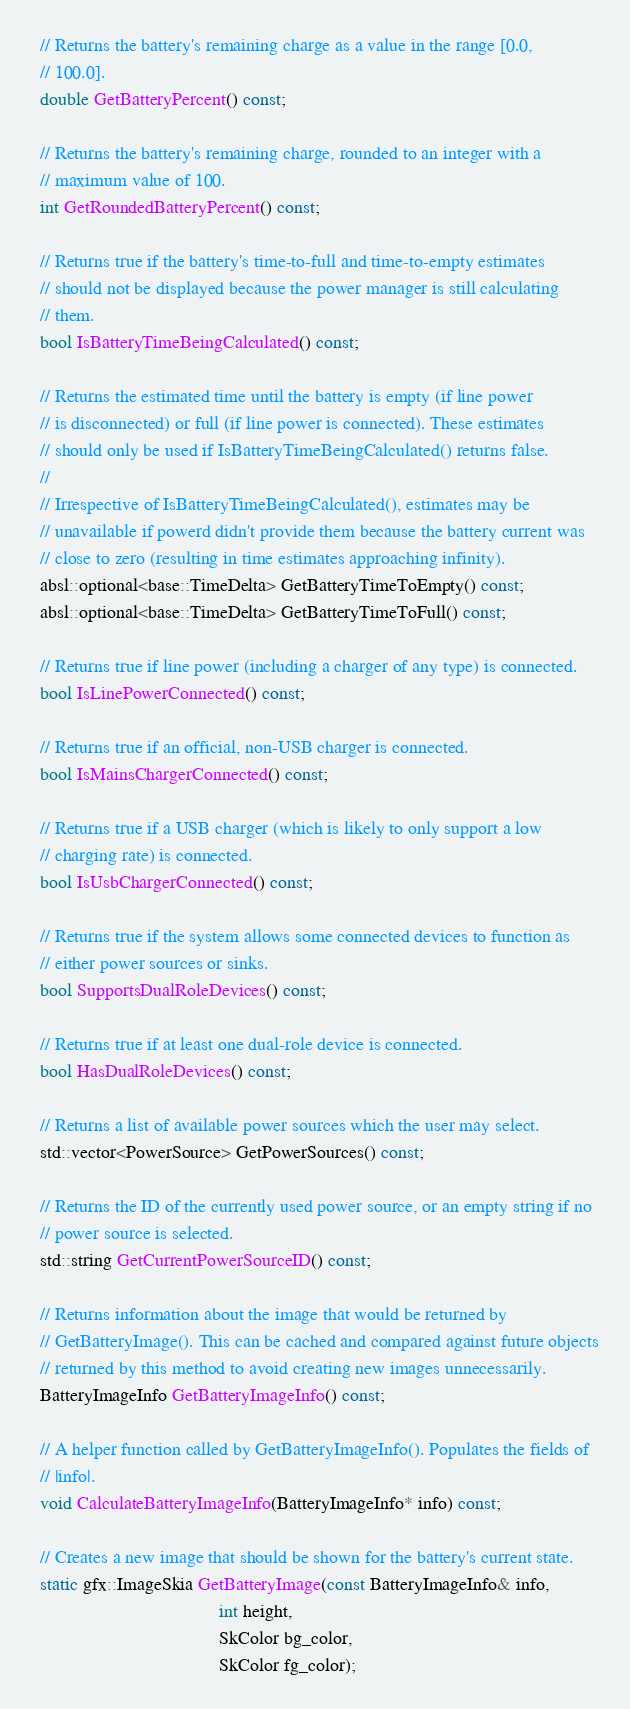<code> <loc_0><loc_0><loc_500><loc_500><_C_>
  // Returns the battery's remaining charge as a value in the range [0.0,
  // 100.0].
  double GetBatteryPercent() const;

  // Returns the battery's remaining charge, rounded to an integer with a
  // maximum value of 100.
  int GetRoundedBatteryPercent() const;

  // Returns true if the battery's time-to-full and time-to-empty estimates
  // should not be displayed because the power manager is still calculating
  // them.
  bool IsBatteryTimeBeingCalculated() const;

  // Returns the estimated time until the battery is empty (if line power
  // is disconnected) or full (if line power is connected). These estimates
  // should only be used if IsBatteryTimeBeingCalculated() returns false.
  //
  // Irrespective of IsBatteryTimeBeingCalculated(), estimates may be
  // unavailable if powerd didn't provide them because the battery current was
  // close to zero (resulting in time estimates approaching infinity).
  absl::optional<base::TimeDelta> GetBatteryTimeToEmpty() const;
  absl::optional<base::TimeDelta> GetBatteryTimeToFull() const;

  // Returns true if line power (including a charger of any type) is connected.
  bool IsLinePowerConnected() const;

  // Returns true if an official, non-USB charger is connected.
  bool IsMainsChargerConnected() const;

  // Returns true if a USB charger (which is likely to only support a low
  // charging rate) is connected.
  bool IsUsbChargerConnected() const;

  // Returns true if the system allows some connected devices to function as
  // either power sources or sinks.
  bool SupportsDualRoleDevices() const;

  // Returns true if at least one dual-role device is connected.
  bool HasDualRoleDevices() const;

  // Returns a list of available power sources which the user may select.
  std::vector<PowerSource> GetPowerSources() const;

  // Returns the ID of the currently used power source, or an empty string if no
  // power source is selected.
  std::string GetCurrentPowerSourceID() const;

  // Returns information about the image that would be returned by
  // GetBatteryImage(). This can be cached and compared against future objects
  // returned by this method to avoid creating new images unnecessarily.
  BatteryImageInfo GetBatteryImageInfo() const;

  // A helper function called by GetBatteryImageInfo(). Populates the fields of
  // |info|.
  void CalculateBatteryImageInfo(BatteryImageInfo* info) const;

  // Creates a new image that should be shown for the battery's current state.
  static gfx::ImageSkia GetBatteryImage(const BatteryImageInfo& info,
                                        int height,
                                        SkColor bg_color,
                                        SkColor fg_color);
</code> 